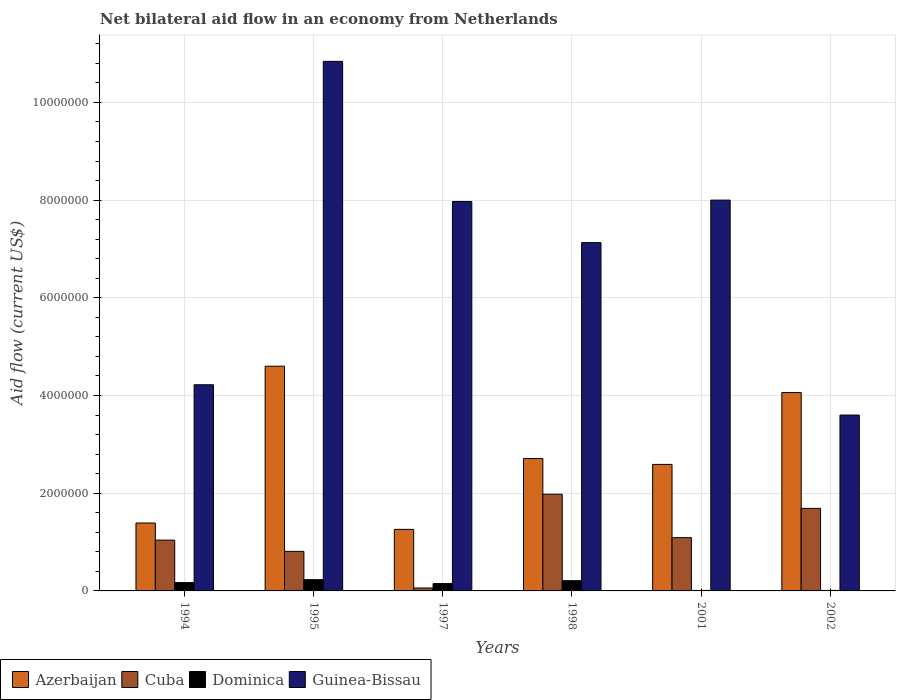How many groups of bars are there?
Give a very brief answer. 6. Are the number of bars on each tick of the X-axis equal?
Offer a terse response. Yes. What is the net bilateral aid flow in Dominica in 1997?
Give a very brief answer. 1.50e+05. Across all years, what is the maximum net bilateral aid flow in Dominica?
Offer a very short reply. 2.30e+05. Across all years, what is the minimum net bilateral aid flow in Azerbaijan?
Provide a succinct answer. 1.26e+06. In which year was the net bilateral aid flow in Guinea-Bissau maximum?
Ensure brevity in your answer.  1995. What is the total net bilateral aid flow in Azerbaijan in the graph?
Your response must be concise. 1.66e+07. What is the difference between the net bilateral aid flow in Azerbaijan in 1994 and that in 1995?
Provide a short and direct response. -3.21e+06. What is the difference between the net bilateral aid flow in Guinea-Bissau in 2002 and the net bilateral aid flow in Azerbaijan in 1994?
Ensure brevity in your answer.  2.21e+06. What is the average net bilateral aid flow in Cuba per year?
Keep it short and to the point. 1.11e+06. In the year 1995, what is the difference between the net bilateral aid flow in Dominica and net bilateral aid flow in Azerbaijan?
Provide a short and direct response. -4.37e+06. In how many years, is the net bilateral aid flow in Cuba greater than 2400000 US$?
Offer a very short reply. 0. What is the ratio of the net bilateral aid flow in Azerbaijan in 1994 to that in 1998?
Offer a very short reply. 0.51. Is the net bilateral aid flow in Guinea-Bissau in 1995 less than that in 2002?
Make the answer very short. No. What is the difference between the highest and the second highest net bilateral aid flow in Azerbaijan?
Your answer should be compact. 5.40e+05. What is the difference between the highest and the lowest net bilateral aid flow in Azerbaijan?
Ensure brevity in your answer.  3.34e+06. In how many years, is the net bilateral aid flow in Dominica greater than the average net bilateral aid flow in Dominica taken over all years?
Your answer should be very brief. 4. What does the 2nd bar from the left in 1994 represents?
Offer a terse response. Cuba. What does the 1st bar from the right in 2002 represents?
Provide a short and direct response. Guinea-Bissau. Is it the case that in every year, the sum of the net bilateral aid flow in Dominica and net bilateral aid flow in Guinea-Bissau is greater than the net bilateral aid flow in Cuba?
Your answer should be compact. Yes. How many bars are there?
Provide a succinct answer. 24. How many years are there in the graph?
Keep it short and to the point. 6. Where does the legend appear in the graph?
Make the answer very short. Bottom left. What is the title of the graph?
Provide a short and direct response. Net bilateral aid flow in an economy from Netherlands. Does "Greece" appear as one of the legend labels in the graph?
Ensure brevity in your answer.  No. What is the label or title of the Y-axis?
Keep it short and to the point. Aid flow (current US$). What is the Aid flow (current US$) of Azerbaijan in 1994?
Offer a terse response. 1.39e+06. What is the Aid flow (current US$) in Cuba in 1994?
Your answer should be very brief. 1.04e+06. What is the Aid flow (current US$) in Dominica in 1994?
Your response must be concise. 1.70e+05. What is the Aid flow (current US$) of Guinea-Bissau in 1994?
Provide a succinct answer. 4.22e+06. What is the Aid flow (current US$) in Azerbaijan in 1995?
Give a very brief answer. 4.60e+06. What is the Aid flow (current US$) of Cuba in 1995?
Offer a terse response. 8.10e+05. What is the Aid flow (current US$) of Dominica in 1995?
Your response must be concise. 2.30e+05. What is the Aid flow (current US$) in Guinea-Bissau in 1995?
Keep it short and to the point. 1.08e+07. What is the Aid flow (current US$) in Azerbaijan in 1997?
Offer a very short reply. 1.26e+06. What is the Aid flow (current US$) in Cuba in 1997?
Offer a very short reply. 6.00e+04. What is the Aid flow (current US$) in Dominica in 1997?
Your answer should be compact. 1.50e+05. What is the Aid flow (current US$) of Guinea-Bissau in 1997?
Keep it short and to the point. 7.97e+06. What is the Aid flow (current US$) in Azerbaijan in 1998?
Give a very brief answer. 2.71e+06. What is the Aid flow (current US$) in Cuba in 1998?
Ensure brevity in your answer.  1.98e+06. What is the Aid flow (current US$) of Dominica in 1998?
Provide a short and direct response. 2.10e+05. What is the Aid flow (current US$) of Guinea-Bissau in 1998?
Your answer should be compact. 7.13e+06. What is the Aid flow (current US$) in Azerbaijan in 2001?
Ensure brevity in your answer.  2.59e+06. What is the Aid flow (current US$) of Cuba in 2001?
Your answer should be compact. 1.09e+06. What is the Aid flow (current US$) in Guinea-Bissau in 2001?
Your answer should be compact. 8.00e+06. What is the Aid flow (current US$) of Azerbaijan in 2002?
Ensure brevity in your answer.  4.06e+06. What is the Aid flow (current US$) in Cuba in 2002?
Make the answer very short. 1.69e+06. What is the Aid flow (current US$) in Guinea-Bissau in 2002?
Your response must be concise. 3.60e+06. Across all years, what is the maximum Aid flow (current US$) of Azerbaijan?
Your answer should be compact. 4.60e+06. Across all years, what is the maximum Aid flow (current US$) of Cuba?
Ensure brevity in your answer.  1.98e+06. Across all years, what is the maximum Aid flow (current US$) in Guinea-Bissau?
Offer a terse response. 1.08e+07. Across all years, what is the minimum Aid flow (current US$) of Azerbaijan?
Your response must be concise. 1.26e+06. Across all years, what is the minimum Aid flow (current US$) in Dominica?
Ensure brevity in your answer.  10000. Across all years, what is the minimum Aid flow (current US$) of Guinea-Bissau?
Keep it short and to the point. 3.60e+06. What is the total Aid flow (current US$) in Azerbaijan in the graph?
Give a very brief answer. 1.66e+07. What is the total Aid flow (current US$) of Cuba in the graph?
Your response must be concise. 6.67e+06. What is the total Aid flow (current US$) in Dominica in the graph?
Keep it short and to the point. 7.80e+05. What is the total Aid flow (current US$) in Guinea-Bissau in the graph?
Offer a terse response. 4.18e+07. What is the difference between the Aid flow (current US$) in Azerbaijan in 1994 and that in 1995?
Offer a very short reply. -3.21e+06. What is the difference between the Aid flow (current US$) of Cuba in 1994 and that in 1995?
Your answer should be very brief. 2.30e+05. What is the difference between the Aid flow (current US$) in Guinea-Bissau in 1994 and that in 1995?
Your answer should be very brief. -6.62e+06. What is the difference between the Aid flow (current US$) in Cuba in 1994 and that in 1997?
Make the answer very short. 9.80e+05. What is the difference between the Aid flow (current US$) of Dominica in 1994 and that in 1997?
Keep it short and to the point. 2.00e+04. What is the difference between the Aid flow (current US$) in Guinea-Bissau in 1994 and that in 1997?
Make the answer very short. -3.75e+06. What is the difference between the Aid flow (current US$) in Azerbaijan in 1994 and that in 1998?
Give a very brief answer. -1.32e+06. What is the difference between the Aid flow (current US$) of Cuba in 1994 and that in 1998?
Your answer should be compact. -9.40e+05. What is the difference between the Aid flow (current US$) in Dominica in 1994 and that in 1998?
Provide a short and direct response. -4.00e+04. What is the difference between the Aid flow (current US$) in Guinea-Bissau in 1994 and that in 1998?
Make the answer very short. -2.91e+06. What is the difference between the Aid flow (current US$) of Azerbaijan in 1994 and that in 2001?
Offer a very short reply. -1.20e+06. What is the difference between the Aid flow (current US$) of Dominica in 1994 and that in 2001?
Your answer should be compact. 1.60e+05. What is the difference between the Aid flow (current US$) of Guinea-Bissau in 1994 and that in 2001?
Your answer should be very brief. -3.78e+06. What is the difference between the Aid flow (current US$) of Azerbaijan in 1994 and that in 2002?
Keep it short and to the point. -2.67e+06. What is the difference between the Aid flow (current US$) of Cuba in 1994 and that in 2002?
Keep it short and to the point. -6.50e+05. What is the difference between the Aid flow (current US$) in Dominica in 1994 and that in 2002?
Your answer should be compact. 1.60e+05. What is the difference between the Aid flow (current US$) of Guinea-Bissau in 1994 and that in 2002?
Your response must be concise. 6.20e+05. What is the difference between the Aid flow (current US$) in Azerbaijan in 1995 and that in 1997?
Your answer should be compact. 3.34e+06. What is the difference between the Aid flow (current US$) of Cuba in 1995 and that in 1997?
Offer a very short reply. 7.50e+05. What is the difference between the Aid flow (current US$) of Dominica in 1995 and that in 1997?
Your answer should be compact. 8.00e+04. What is the difference between the Aid flow (current US$) of Guinea-Bissau in 1995 and that in 1997?
Provide a short and direct response. 2.87e+06. What is the difference between the Aid flow (current US$) of Azerbaijan in 1995 and that in 1998?
Offer a terse response. 1.89e+06. What is the difference between the Aid flow (current US$) in Cuba in 1995 and that in 1998?
Provide a succinct answer. -1.17e+06. What is the difference between the Aid flow (current US$) of Guinea-Bissau in 1995 and that in 1998?
Offer a terse response. 3.71e+06. What is the difference between the Aid flow (current US$) of Azerbaijan in 1995 and that in 2001?
Your answer should be compact. 2.01e+06. What is the difference between the Aid flow (current US$) in Cuba in 1995 and that in 2001?
Your answer should be compact. -2.80e+05. What is the difference between the Aid flow (current US$) of Guinea-Bissau in 1995 and that in 2001?
Your answer should be compact. 2.84e+06. What is the difference between the Aid flow (current US$) of Azerbaijan in 1995 and that in 2002?
Your answer should be compact. 5.40e+05. What is the difference between the Aid flow (current US$) in Cuba in 1995 and that in 2002?
Keep it short and to the point. -8.80e+05. What is the difference between the Aid flow (current US$) of Guinea-Bissau in 1995 and that in 2002?
Your answer should be very brief. 7.24e+06. What is the difference between the Aid flow (current US$) in Azerbaijan in 1997 and that in 1998?
Give a very brief answer. -1.45e+06. What is the difference between the Aid flow (current US$) of Cuba in 1997 and that in 1998?
Make the answer very short. -1.92e+06. What is the difference between the Aid flow (current US$) of Dominica in 1997 and that in 1998?
Keep it short and to the point. -6.00e+04. What is the difference between the Aid flow (current US$) of Guinea-Bissau in 1997 and that in 1998?
Keep it short and to the point. 8.40e+05. What is the difference between the Aid flow (current US$) in Azerbaijan in 1997 and that in 2001?
Your response must be concise. -1.33e+06. What is the difference between the Aid flow (current US$) of Cuba in 1997 and that in 2001?
Ensure brevity in your answer.  -1.03e+06. What is the difference between the Aid flow (current US$) in Dominica in 1997 and that in 2001?
Provide a succinct answer. 1.40e+05. What is the difference between the Aid flow (current US$) of Guinea-Bissau in 1997 and that in 2001?
Give a very brief answer. -3.00e+04. What is the difference between the Aid flow (current US$) in Azerbaijan in 1997 and that in 2002?
Your answer should be compact. -2.80e+06. What is the difference between the Aid flow (current US$) in Cuba in 1997 and that in 2002?
Provide a short and direct response. -1.63e+06. What is the difference between the Aid flow (current US$) of Guinea-Bissau in 1997 and that in 2002?
Provide a succinct answer. 4.37e+06. What is the difference between the Aid flow (current US$) of Azerbaijan in 1998 and that in 2001?
Provide a short and direct response. 1.20e+05. What is the difference between the Aid flow (current US$) in Cuba in 1998 and that in 2001?
Ensure brevity in your answer.  8.90e+05. What is the difference between the Aid flow (current US$) of Guinea-Bissau in 1998 and that in 2001?
Your answer should be compact. -8.70e+05. What is the difference between the Aid flow (current US$) in Azerbaijan in 1998 and that in 2002?
Keep it short and to the point. -1.35e+06. What is the difference between the Aid flow (current US$) of Dominica in 1998 and that in 2002?
Keep it short and to the point. 2.00e+05. What is the difference between the Aid flow (current US$) of Guinea-Bissau in 1998 and that in 2002?
Keep it short and to the point. 3.53e+06. What is the difference between the Aid flow (current US$) of Azerbaijan in 2001 and that in 2002?
Offer a very short reply. -1.47e+06. What is the difference between the Aid flow (current US$) in Cuba in 2001 and that in 2002?
Offer a terse response. -6.00e+05. What is the difference between the Aid flow (current US$) in Dominica in 2001 and that in 2002?
Your answer should be compact. 0. What is the difference between the Aid flow (current US$) of Guinea-Bissau in 2001 and that in 2002?
Offer a very short reply. 4.40e+06. What is the difference between the Aid flow (current US$) in Azerbaijan in 1994 and the Aid flow (current US$) in Cuba in 1995?
Offer a terse response. 5.80e+05. What is the difference between the Aid flow (current US$) in Azerbaijan in 1994 and the Aid flow (current US$) in Dominica in 1995?
Your answer should be compact. 1.16e+06. What is the difference between the Aid flow (current US$) in Azerbaijan in 1994 and the Aid flow (current US$) in Guinea-Bissau in 1995?
Offer a terse response. -9.45e+06. What is the difference between the Aid flow (current US$) of Cuba in 1994 and the Aid flow (current US$) of Dominica in 1995?
Offer a very short reply. 8.10e+05. What is the difference between the Aid flow (current US$) in Cuba in 1994 and the Aid flow (current US$) in Guinea-Bissau in 1995?
Ensure brevity in your answer.  -9.80e+06. What is the difference between the Aid flow (current US$) of Dominica in 1994 and the Aid flow (current US$) of Guinea-Bissau in 1995?
Provide a short and direct response. -1.07e+07. What is the difference between the Aid flow (current US$) of Azerbaijan in 1994 and the Aid flow (current US$) of Cuba in 1997?
Offer a terse response. 1.33e+06. What is the difference between the Aid flow (current US$) of Azerbaijan in 1994 and the Aid flow (current US$) of Dominica in 1997?
Ensure brevity in your answer.  1.24e+06. What is the difference between the Aid flow (current US$) in Azerbaijan in 1994 and the Aid flow (current US$) in Guinea-Bissau in 1997?
Provide a succinct answer. -6.58e+06. What is the difference between the Aid flow (current US$) in Cuba in 1994 and the Aid flow (current US$) in Dominica in 1997?
Offer a very short reply. 8.90e+05. What is the difference between the Aid flow (current US$) in Cuba in 1994 and the Aid flow (current US$) in Guinea-Bissau in 1997?
Give a very brief answer. -6.93e+06. What is the difference between the Aid flow (current US$) of Dominica in 1994 and the Aid flow (current US$) of Guinea-Bissau in 1997?
Your answer should be compact. -7.80e+06. What is the difference between the Aid flow (current US$) of Azerbaijan in 1994 and the Aid flow (current US$) of Cuba in 1998?
Your answer should be compact. -5.90e+05. What is the difference between the Aid flow (current US$) of Azerbaijan in 1994 and the Aid flow (current US$) of Dominica in 1998?
Ensure brevity in your answer.  1.18e+06. What is the difference between the Aid flow (current US$) in Azerbaijan in 1994 and the Aid flow (current US$) in Guinea-Bissau in 1998?
Your answer should be very brief. -5.74e+06. What is the difference between the Aid flow (current US$) in Cuba in 1994 and the Aid flow (current US$) in Dominica in 1998?
Your response must be concise. 8.30e+05. What is the difference between the Aid flow (current US$) in Cuba in 1994 and the Aid flow (current US$) in Guinea-Bissau in 1998?
Your answer should be very brief. -6.09e+06. What is the difference between the Aid flow (current US$) in Dominica in 1994 and the Aid flow (current US$) in Guinea-Bissau in 1998?
Provide a short and direct response. -6.96e+06. What is the difference between the Aid flow (current US$) of Azerbaijan in 1994 and the Aid flow (current US$) of Cuba in 2001?
Give a very brief answer. 3.00e+05. What is the difference between the Aid flow (current US$) in Azerbaijan in 1994 and the Aid flow (current US$) in Dominica in 2001?
Offer a very short reply. 1.38e+06. What is the difference between the Aid flow (current US$) of Azerbaijan in 1994 and the Aid flow (current US$) of Guinea-Bissau in 2001?
Offer a very short reply. -6.61e+06. What is the difference between the Aid flow (current US$) of Cuba in 1994 and the Aid flow (current US$) of Dominica in 2001?
Your answer should be very brief. 1.03e+06. What is the difference between the Aid flow (current US$) in Cuba in 1994 and the Aid flow (current US$) in Guinea-Bissau in 2001?
Give a very brief answer. -6.96e+06. What is the difference between the Aid flow (current US$) of Dominica in 1994 and the Aid flow (current US$) of Guinea-Bissau in 2001?
Provide a short and direct response. -7.83e+06. What is the difference between the Aid flow (current US$) in Azerbaijan in 1994 and the Aid flow (current US$) in Dominica in 2002?
Your answer should be very brief. 1.38e+06. What is the difference between the Aid flow (current US$) of Azerbaijan in 1994 and the Aid flow (current US$) of Guinea-Bissau in 2002?
Your response must be concise. -2.21e+06. What is the difference between the Aid flow (current US$) in Cuba in 1994 and the Aid flow (current US$) in Dominica in 2002?
Offer a terse response. 1.03e+06. What is the difference between the Aid flow (current US$) of Cuba in 1994 and the Aid flow (current US$) of Guinea-Bissau in 2002?
Make the answer very short. -2.56e+06. What is the difference between the Aid flow (current US$) of Dominica in 1994 and the Aid flow (current US$) of Guinea-Bissau in 2002?
Provide a succinct answer. -3.43e+06. What is the difference between the Aid flow (current US$) of Azerbaijan in 1995 and the Aid flow (current US$) of Cuba in 1997?
Give a very brief answer. 4.54e+06. What is the difference between the Aid flow (current US$) of Azerbaijan in 1995 and the Aid flow (current US$) of Dominica in 1997?
Your response must be concise. 4.45e+06. What is the difference between the Aid flow (current US$) in Azerbaijan in 1995 and the Aid flow (current US$) in Guinea-Bissau in 1997?
Make the answer very short. -3.37e+06. What is the difference between the Aid flow (current US$) of Cuba in 1995 and the Aid flow (current US$) of Dominica in 1997?
Give a very brief answer. 6.60e+05. What is the difference between the Aid flow (current US$) of Cuba in 1995 and the Aid flow (current US$) of Guinea-Bissau in 1997?
Provide a short and direct response. -7.16e+06. What is the difference between the Aid flow (current US$) of Dominica in 1995 and the Aid flow (current US$) of Guinea-Bissau in 1997?
Your response must be concise. -7.74e+06. What is the difference between the Aid flow (current US$) of Azerbaijan in 1995 and the Aid flow (current US$) of Cuba in 1998?
Your response must be concise. 2.62e+06. What is the difference between the Aid flow (current US$) of Azerbaijan in 1995 and the Aid flow (current US$) of Dominica in 1998?
Give a very brief answer. 4.39e+06. What is the difference between the Aid flow (current US$) of Azerbaijan in 1995 and the Aid flow (current US$) of Guinea-Bissau in 1998?
Provide a succinct answer. -2.53e+06. What is the difference between the Aid flow (current US$) in Cuba in 1995 and the Aid flow (current US$) in Guinea-Bissau in 1998?
Keep it short and to the point. -6.32e+06. What is the difference between the Aid flow (current US$) of Dominica in 1995 and the Aid flow (current US$) of Guinea-Bissau in 1998?
Your response must be concise. -6.90e+06. What is the difference between the Aid flow (current US$) of Azerbaijan in 1995 and the Aid flow (current US$) of Cuba in 2001?
Offer a very short reply. 3.51e+06. What is the difference between the Aid flow (current US$) in Azerbaijan in 1995 and the Aid flow (current US$) in Dominica in 2001?
Provide a succinct answer. 4.59e+06. What is the difference between the Aid flow (current US$) in Azerbaijan in 1995 and the Aid flow (current US$) in Guinea-Bissau in 2001?
Provide a short and direct response. -3.40e+06. What is the difference between the Aid flow (current US$) in Cuba in 1995 and the Aid flow (current US$) in Guinea-Bissau in 2001?
Keep it short and to the point. -7.19e+06. What is the difference between the Aid flow (current US$) of Dominica in 1995 and the Aid flow (current US$) of Guinea-Bissau in 2001?
Keep it short and to the point. -7.77e+06. What is the difference between the Aid flow (current US$) in Azerbaijan in 1995 and the Aid flow (current US$) in Cuba in 2002?
Offer a terse response. 2.91e+06. What is the difference between the Aid flow (current US$) of Azerbaijan in 1995 and the Aid flow (current US$) of Dominica in 2002?
Your answer should be compact. 4.59e+06. What is the difference between the Aid flow (current US$) in Cuba in 1995 and the Aid flow (current US$) in Guinea-Bissau in 2002?
Provide a succinct answer. -2.79e+06. What is the difference between the Aid flow (current US$) of Dominica in 1995 and the Aid flow (current US$) of Guinea-Bissau in 2002?
Offer a terse response. -3.37e+06. What is the difference between the Aid flow (current US$) in Azerbaijan in 1997 and the Aid flow (current US$) in Cuba in 1998?
Your answer should be compact. -7.20e+05. What is the difference between the Aid flow (current US$) of Azerbaijan in 1997 and the Aid flow (current US$) of Dominica in 1998?
Make the answer very short. 1.05e+06. What is the difference between the Aid flow (current US$) of Azerbaijan in 1997 and the Aid flow (current US$) of Guinea-Bissau in 1998?
Your answer should be compact. -5.87e+06. What is the difference between the Aid flow (current US$) in Cuba in 1997 and the Aid flow (current US$) in Guinea-Bissau in 1998?
Keep it short and to the point. -7.07e+06. What is the difference between the Aid flow (current US$) of Dominica in 1997 and the Aid flow (current US$) of Guinea-Bissau in 1998?
Keep it short and to the point. -6.98e+06. What is the difference between the Aid flow (current US$) of Azerbaijan in 1997 and the Aid flow (current US$) of Cuba in 2001?
Your answer should be very brief. 1.70e+05. What is the difference between the Aid flow (current US$) of Azerbaijan in 1997 and the Aid flow (current US$) of Dominica in 2001?
Give a very brief answer. 1.25e+06. What is the difference between the Aid flow (current US$) of Azerbaijan in 1997 and the Aid flow (current US$) of Guinea-Bissau in 2001?
Offer a terse response. -6.74e+06. What is the difference between the Aid flow (current US$) in Cuba in 1997 and the Aid flow (current US$) in Guinea-Bissau in 2001?
Provide a short and direct response. -7.94e+06. What is the difference between the Aid flow (current US$) of Dominica in 1997 and the Aid flow (current US$) of Guinea-Bissau in 2001?
Your answer should be compact. -7.85e+06. What is the difference between the Aid flow (current US$) of Azerbaijan in 1997 and the Aid flow (current US$) of Cuba in 2002?
Offer a terse response. -4.30e+05. What is the difference between the Aid flow (current US$) in Azerbaijan in 1997 and the Aid flow (current US$) in Dominica in 2002?
Provide a succinct answer. 1.25e+06. What is the difference between the Aid flow (current US$) in Azerbaijan in 1997 and the Aid flow (current US$) in Guinea-Bissau in 2002?
Provide a succinct answer. -2.34e+06. What is the difference between the Aid flow (current US$) in Cuba in 1997 and the Aid flow (current US$) in Guinea-Bissau in 2002?
Make the answer very short. -3.54e+06. What is the difference between the Aid flow (current US$) in Dominica in 1997 and the Aid flow (current US$) in Guinea-Bissau in 2002?
Your answer should be compact. -3.45e+06. What is the difference between the Aid flow (current US$) of Azerbaijan in 1998 and the Aid flow (current US$) of Cuba in 2001?
Your answer should be very brief. 1.62e+06. What is the difference between the Aid flow (current US$) in Azerbaijan in 1998 and the Aid flow (current US$) in Dominica in 2001?
Your answer should be very brief. 2.70e+06. What is the difference between the Aid flow (current US$) of Azerbaijan in 1998 and the Aid flow (current US$) of Guinea-Bissau in 2001?
Give a very brief answer. -5.29e+06. What is the difference between the Aid flow (current US$) of Cuba in 1998 and the Aid flow (current US$) of Dominica in 2001?
Keep it short and to the point. 1.97e+06. What is the difference between the Aid flow (current US$) of Cuba in 1998 and the Aid flow (current US$) of Guinea-Bissau in 2001?
Your answer should be very brief. -6.02e+06. What is the difference between the Aid flow (current US$) of Dominica in 1998 and the Aid flow (current US$) of Guinea-Bissau in 2001?
Your response must be concise. -7.79e+06. What is the difference between the Aid flow (current US$) in Azerbaijan in 1998 and the Aid flow (current US$) in Cuba in 2002?
Give a very brief answer. 1.02e+06. What is the difference between the Aid flow (current US$) in Azerbaijan in 1998 and the Aid flow (current US$) in Dominica in 2002?
Your answer should be compact. 2.70e+06. What is the difference between the Aid flow (current US$) in Azerbaijan in 1998 and the Aid flow (current US$) in Guinea-Bissau in 2002?
Ensure brevity in your answer.  -8.90e+05. What is the difference between the Aid flow (current US$) in Cuba in 1998 and the Aid flow (current US$) in Dominica in 2002?
Give a very brief answer. 1.97e+06. What is the difference between the Aid flow (current US$) in Cuba in 1998 and the Aid flow (current US$) in Guinea-Bissau in 2002?
Make the answer very short. -1.62e+06. What is the difference between the Aid flow (current US$) in Dominica in 1998 and the Aid flow (current US$) in Guinea-Bissau in 2002?
Your answer should be very brief. -3.39e+06. What is the difference between the Aid flow (current US$) of Azerbaijan in 2001 and the Aid flow (current US$) of Cuba in 2002?
Your answer should be very brief. 9.00e+05. What is the difference between the Aid flow (current US$) in Azerbaijan in 2001 and the Aid flow (current US$) in Dominica in 2002?
Your answer should be compact. 2.58e+06. What is the difference between the Aid flow (current US$) of Azerbaijan in 2001 and the Aid flow (current US$) of Guinea-Bissau in 2002?
Offer a very short reply. -1.01e+06. What is the difference between the Aid flow (current US$) in Cuba in 2001 and the Aid flow (current US$) in Dominica in 2002?
Provide a short and direct response. 1.08e+06. What is the difference between the Aid flow (current US$) in Cuba in 2001 and the Aid flow (current US$) in Guinea-Bissau in 2002?
Keep it short and to the point. -2.51e+06. What is the difference between the Aid flow (current US$) of Dominica in 2001 and the Aid flow (current US$) of Guinea-Bissau in 2002?
Your answer should be compact. -3.59e+06. What is the average Aid flow (current US$) in Azerbaijan per year?
Ensure brevity in your answer.  2.77e+06. What is the average Aid flow (current US$) of Cuba per year?
Your answer should be compact. 1.11e+06. What is the average Aid flow (current US$) in Guinea-Bissau per year?
Your answer should be very brief. 6.96e+06. In the year 1994, what is the difference between the Aid flow (current US$) in Azerbaijan and Aid flow (current US$) in Cuba?
Your answer should be compact. 3.50e+05. In the year 1994, what is the difference between the Aid flow (current US$) of Azerbaijan and Aid flow (current US$) of Dominica?
Ensure brevity in your answer.  1.22e+06. In the year 1994, what is the difference between the Aid flow (current US$) of Azerbaijan and Aid flow (current US$) of Guinea-Bissau?
Your response must be concise. -2.83e+06. In the year 1994, what is the difference between the Aid flow (current US$) in Cuba and Aid flow (current US$) in Dominica?
Your answer should be very brief. 8.70e+05. In the year 1994, what is the difference between the Aid flow (current US$) of Cuba and Aid flow (current US$) of Guinea-Bissau?
Keep it short and to the point. -3.18e+06. In the year 1994, what is the difference between the Aid flow (current US$) of Dominica and Aid flow (current US$) of Guinea-Bissau?
Offer a very short reply. -4.05e+06. In the year 1995, what is the difference between the Aid flow (current US$) in Azerbaijan and Aid flow (current US$) in Cuba?
Your answer should be compact. 3.79e+06. In the year 1995, what is the difference between the Aid flow (current US$) in Azerbaijan and Aid flow (current US$) in Dominica?
Your response must be concise. 4.37e+06. In the year 1995, what is the difference between the Aid flow (current US$) of Azerbaijan and Aid flow (current US$) of Guinea-Bissau?
Give a very brief answer. -6.24e+06. In the year 1995, what is the difference between the Aid flow (current US$) in Cuba and Aid flow (current US$) in Dominica?
Provide a succinct answer. 5.80e+05. In the year 1995, what is the difference between the Aid flow (current US$) in Cuba and Aid flow (current US$) in Guinea-Bissau?
Provide a succinct answer. -1.00e+07. In the year 1995, what is the difference between the Aid flow (current US$) in Dominica and Aid flow (current US$) in Guinea-Bissau?
Offer a terse response. -1.06e+07. In the year 1997, what is the difference between the Aid flow (current US$) of Azerbaijan and Aid flow (current US$) of Cuba?
Your answer should be compact. 1.20e+06. In the year 1997, what is the difference between the Aid flow (current US$) in Azerbaijan and Aid flow (current US$) in Dominica?
Give a very brief answer. 1.11e+06. In the year 1997, what is the difference between the Aid flow (current US$) in Azerbaijan and Aid flow (current US$) in Guinea-Bissau?
Your answer should be very brief. -6.71e+06. In the year 1997, what is the difference between the Aid flow (current US$) of Cuba and Aid flow (current US$) of Dominica?
Your response must be concise. -9.00e+04. In the year 1997, what is the difference between the Aid flow (current US$) of Cuba and Aid flow (current US$) of Guinea-Bissau?
Offer a very short reply. -7.91e+06. In the year 1997, what is the difference between the Aid flow (current US$) of Dominica and Aid flow (current US$) of Guinea-Bissau?
Offer a terse response. -7.82e+06. In the year 1998, what is the difference between the Aid flow (current US$) of Azerbaijan and Aid flow (current US$) of Cuba?
Ensure brevity in your answer.  7.30e+05. In the year 1998, what is the difference between the Aid flow (current US$) in Azerbaijan and Aid flow (current US$) in Dominica?
Offer a terse response. 2.50e+06. In the year 1998, what is the difference between the Aid flow (current US$) of Azerbaijan and Aid flow (current US$) of Guinea-Bissau?
Ensure brevity in your answer.  -4.42e+06. In the year 1998, what is the difference between the Aid flow (current US$) of Cuba and Aid flow (current US$) of Dominica?
Offer a very short reply. 1.77e+06. In the year 1998, what is the difference between the Aid flow (current US$) of Cuba and Aid flow (current US$) of Guinea-Bissau?
Ensure brevity in your answer.  -5.15e+06. In the year 1998, what is the difference between the Aid flow (current US$) in Dominica and Aid flow (current US$) in Guinea-Bissau?
Offer a very short reply. -6.92e+06. In the year 2001, what is the difference between the Aid flow (current US$) of Azerbaijan and Aid flow (current US$) of Cuba?
Give a very brief answer. 1.50e+06. In the year 2001, what is the difference between the Aid flow (current US$) of Azerbaijan and Aid flow (current US$) of Dominica?
Keep it short and to the point. 2.58e+06. In the year 2001, what is the difference between the Aid flow (current US$) of Azerbaijan and Aid flow (current US$) of Guinea-Bissau?
Offer a terse response. -5.41e+06. In the year 2001, what is the difference between the Aid flow (current US$) in Cuba and Aid flow (current US$) in Dominica?
Your answer should be compact. 1.08e+06. In the year 2001, what is the difference between the Aid flow (current US$) of Cuba and Aid flow (current US$) of Guinea-Bissau?
Your answer should be very brief. -6.91e+06. In the year 2001, what is the difference between the Aid flow (current US$) of Dominica and Aid flow (current US$) of Guinea-Bissau?
Keep it short and to the point. -7.99e+06. In the year 2002, what is the difference between the Aid flow (current US$) of Azerbaijan and Aid flow (current US$) of Cuba?
Offer a terse response. 2.37e+06. In the year 2002, what is the difference between the Aid flow (current US$) in Azerbaijan and Aid flow (current US$) in Dominica?
Keep it short and to the point. 4.05e+06. In the year 2002, what is the difference between the Aid flow (current US$) of Cuba and Aid flow (current US$) of Dominica?
Offer a very short reply. 1.68e+06. In the year 2002, what is the difference between the Aid flow (current US$) in Cuba and Aid flow (current US$) in Guinea-Bissau?
Your response must be concise. -1.91e+06. In the year 2002, what is the difference between the Aid flow (current US$) of Dominica and Aid flow (current US$) of Guinea-Bissau?
Offer a very short reply. -3.59e+06. What is the ratio of the Aid flow (current US$) in Azerbaijan in 1994 to that in 1995?
Offer a very short reply. 0.3. What is the ratio of the Aid flow (current US$) of Cuba in 1994 to that in 1995?
Offer a terse response. 1.28. What is the ratio of the Aid flow (current US$) of Dominica in 1994 to that in 1995?
Offer a terse response. 0.74. What is the ratio of the Aid flow (current US$) of Guinea-Bissau in 1994 to that in 1995?
Provide a succinct answer. 0.39. What is the ratio of the Aid flow (current US$) in Azerbaijan in 1994 to that in 1997?
Offer a terse response. 1.1. What is the ratio of the Aid flow (current US$) of Cuba in 1994 to that in 1997?
Your answer should be compact. 17.33. What is the ratio of the Aid flow (current US$) in Dominica in 1994 to that in 1997?
Offer a terse response. 1.13. What is the ratio of the Aid flow (current US$) of Guinea-Bissau in 1994 to that in 1997?
Ensure brevity in your answer.  0.53. What is the ratio of the Aid flow (current US$) in Azerbaijan in 1994 to that in 1998?
Your response must be concise. 0.51. What is the ratio of the Aid flow (current US$) in Cuba in 1994 to that in 1998?
Offer a very short reply. 0.53. What is the ratio of the Aid flow (current US$) of Dominica in 1994 to that in 1998?
Keep it short and to the point. 0.81. What is the ratio of the Aid flow (current US$) in Guinea-Bissau in 1994 to that in 1998?
Your answer should be very brief. 0.59. What is the ratio of the Aid flow (current US$) of Azerbaijan in 1994 to that in 2001?
Offer a terse response. 0.54. What is the ratio of the Aid flow (current US$) of Cuba in 1994 to that in 2001?
Offer a very short reply. 0.95. What is the ratio of the Aid flow (current US$) in Dominica in 1994 to that in 2001?
Your response must be concise. 17. What is the ratio of the Aid flow (current US$) in Guinea-Bissau in 1994 to that in 2001?
Your answer should be very brief. 0.53. What is the ratio of the Aid flow (current US$) of Azerbaijan in 1994 to that in 2002?
Offer a terse response. 0.34. What is the ratio of the Aid flow (current US$) of Cuba in 1994 to that in 2002?
Your answer should be compact. 0.62. What is the ratio of the Aid flow (current US$) in Dominica in 1994 to that in 2002?
Provide a short and direct response. 17. What is the ratio of the Aid flow (current US$) of Guinea-Bissau in 1994 to that in 2002?
Provide a succinct answer. 1.17. What is the ratio of the Aid flow (current US$) in Azerbaijan in 1995 to that in 1997?
Provide a succinct answer. 3.65. What is the ratio of the Aid flow (current US$) of Cuba in 1995 to that in 1997?
Your response must be concise. 13.5. What is the ratio of the Aid flow (current US$) in Dominica in 1995 to that in 1997?
Provide a short and direct response. 1.53. What is the ratio of the Aid flow (current US$) in Guinea-Bissau in 1995 to that in 1997?
Keep it short and to the point. 1.36. What is the ratio of the Aid flow (current US$) of Azerbaijan in 1995 to that in 1998?
Ensure brevity in your answer.  1.7. What is the ratio of the Aid flow (current US$) in Cuba in 1995 to that in 1998?
Your answer should be compact. 0.41. What is the ratio of the Aid flow (current US$) in Dominica in 1995 to that in 1998?
Offer a terse response. 1.1. What is the ratio of the Aid flow (current US$) of Guinea-Bissau in 1995 to that in 1998?
Provide a succinct answer. 1.52. What is the ratio of the Aid flow (current US$) of Azerbaijan in 1995 to that in 2001?
Provide a short and direct response. 1.78. What is the ratio of the Aid flow (current US$) in Cuba in 1995 to that in 2001?
Provide a short and direct response. 0.74. What is the ratio of the Aid flow (current US$) of Guinea-Bissau in 1995 to that in 2001?
Your answer should be very brief. 1.35. What is the ratio of the Aid flow (current US$) of Azerbaijan in 1995 to that in 2002?
Keep it short and to the point. 1.13. What is the ratio of the Aid flow (current US$) in Cuba in 1995 to that in 2002?
Your answer should be very brief. 0.48. What is the ratio of the Aid flow (current US$) in Dominica in 1995 to that in 2002?
Your answer should be compact. 23. What is the ratio of the Aid flow (current US$) in Guinea-Bissau in 1995 to that in 2002?
Your response must be concise. 3.01. What is the ratio of the Aid flow (current US$) of Azerbaijan in 1997 to that in 1998?
Keep it short and to the point. 0.46. What is the ratio of the Aid flow (current US$) of Cuba in 1997 to that in 1998?
Ensure brevity in your answer.  0.03. What is the ratio of the Aid flow (current US$) in Dominica in 1997 to that in 1998?
Offer a very short reply. 0.71. What is the ratio of the Aid flow (current US$) of Guinea-Bissau in 1997 to that in 1998?
Your response must be concise. 1.12. What is the ratio of the Aid flow (current US$) in Azerbaijan in 1997 to that in 2001?
Ensure brevity in your answer.  0.49. What is the ratio of the Aid flow (current US$) in Cuba in 1997 to that in 2001?
Provide a succinct answer. 0.06. What is the ratio of the Aid flow (current US$) of Dominica in 1997 to that in 2001?
Make the answer very short. 15. What is the ratio of the Aid flow (current US$) of Guinea-Bissau in 1997 to that in 2001?
Offer a terse response. 1. What is the ratio of the Aid flow (current US$) of Azerbaijan in 1997 to that in 2002?
Your response must be concise. 0.31. What is the ratio of the Aid flow (current US$) in Cuba in 1997 to that in 2002?
Offer a very short reply. 0.04. What is the ratio of the Aid flow (current US$) of Guinea-Bissau in 1997 to that in 2002?
Your answer should be compact. 2.21. What is the ratio of the Aid flow (current US$) in Azerbaijan in 1998 to that in 2001?
Offer a very short reply. 1.05. What is the ratio of the Aid flow (current US$) of Cuba in 1998 to that in 2001?
Provide a succinct answer. 1.82. What is the ratio of the Aid flow (current US$) of Dominica in 1998 to that in 2001?
Keep it short and to the point. 21. What is the ratio of the Aid flow (current US$) of Guinea-Bissau in 1998 to that in 2001?
Make the answer very short. 0.89. What is the ratio of the Aid flow (current US$) of Azerbaijan in 1998 to that in 2002?
Offer a very short reply. 0.67. What is the ratio of the Aid flow (current US$) of Cuba in 1998 to that in 2002?
Provide a succinct answer. 1.17. What is the ratio of the Aid flow (current US$) in Guinea-Bissau in 1998 to that in 2002?
Your response must be concise. 1.98. What is the ratio of the Aid flow (current US$) of Azerbaijan in 2001 to that in 2002?
Ensure brevity in your answer.  0.64. What is the ratio of the Aid flow (current US$) in Cuba in 2001 to that in 2002?
Provide a short and direct response. 0.65. What is the ratio of the Aid flow (current US$) of Guinea-Bissau in 2001 to that in 2002?
Your answer should be compact. 2.22. What is the difference between the highest and the second highest Aid flow (current US$) of Azerbaijan?
Offer a terse response. 5.40e+05. What is the difference between the highest and the second highest Aid flow (current US$) in Dominica?
Your response must be concise. 2.00e+04. What is the difference between the highest and the second highest Aid flow (current US$) of Guinea-Bissau?
Offer a terse response. 2.84e+06. What is the difference between the highest and the lowest Aid flow (current US$) in Azerbaijan?
Provide a short and direct response. 3.34e+06. What is the difference between the highest and the lowest Aid flow (current US$) of Cuba?
Your response must be concise. 1.92e+06. What is the difference between the highest and the lowest Aid flow (current US$) of Guinea-Bissau?
Your response must be concise. 7.24e+06. 